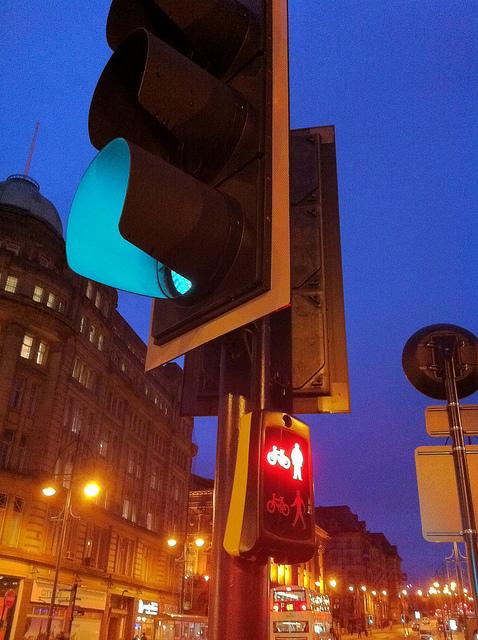Is it night time?
Keep it brief. Yes. What color is the traffic light?
Be succinct. Green. Is it safe for people to walk across the crosswalk now?
Write a very short answer. No. 